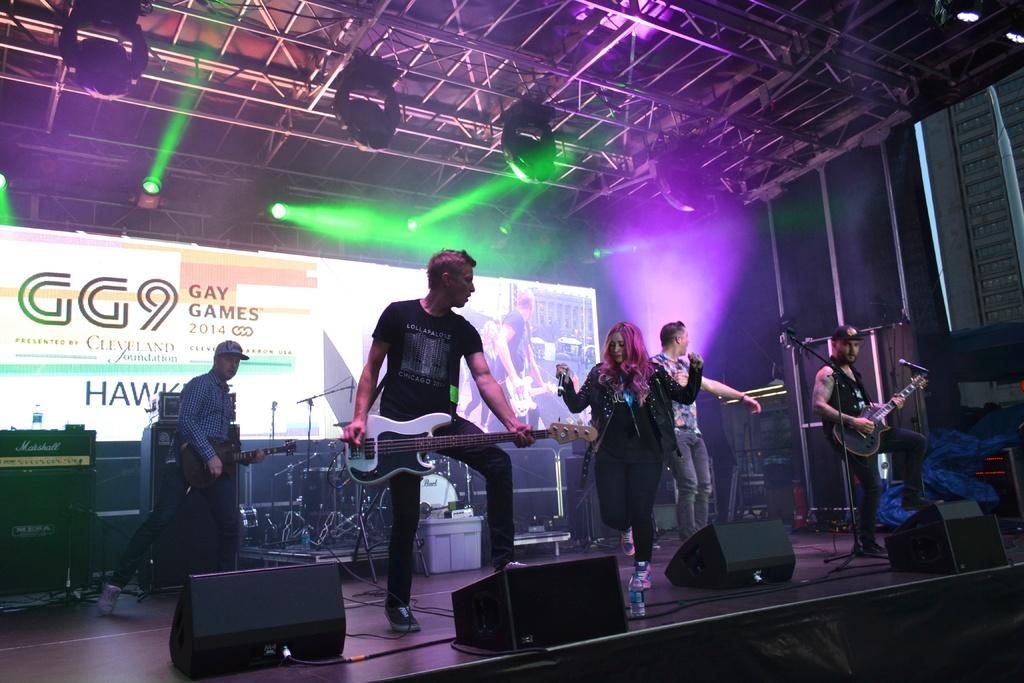How would you summarize this image in a sentence or two? In this image I can see few people are standing on the stage. In the background there is a board and these people are playing the guitars. In the middle there is a woman is holding a mike in her hand. On the top of the I can see some lights. 